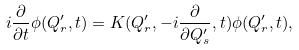<formula> <loc_0><loc_0><loc_500><loc_500>i \frac { \partial } { \partial t } \phi ( Q _ { r } ^ { \prime } , t ) = K ( Q _ { r } ^ { \prime } , - i \frac { \partial } { \partial Q _ { s } ^ { \prime } } , t ) \phi ( Q _ { r } ^ { \prime } , t ) ,</formula> 